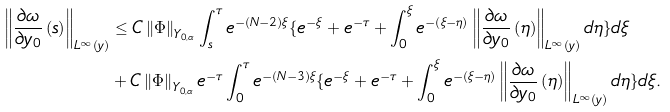Convert formula to latex. <formula><loc_0><loc_0><loc_500><loc_500>\left \| \frac { \partial \omega } { \partial y _ { 0 } } \left ( s \right ) \right \| _ { L ^ { \infty } \left ( y \right ) } & \leq C \left \| \Phi \right \| _ { Y _ { 0 , \alpha } } \int _ { s } ^ { \tau } e ^ { - \left ( N - 2 \right ) \xi } \{ e ^ { - \xi } + e ^ { - \tau } + \int _ { 0 } ^ { \xi } e ^ { - \left ( \xi - \eta \right ) } \left \| \frac { \partial \omega } { \partial y _ { 0 } } \left ( \eta \right ) \right \| _ { L ^ { \infty } \left ( y \right ) } d \eta \} d \xi \\ & + C \left \| \Phi \right \| _ { Y _ { 0 , \alpha } } e ^ { - \tau } \int _ { 0 } ^ { \tau } e ^ { - \left ( N - 3 \right ) \xi } \{ e ^ { - \xi } + e ^ { - \tau } + \int _ { 0 } ^ { \xi } e ^ { - \left ( \xi - \eta \right ) } \left \| \frac { \partial \omega } { \partial y _ { 0 } } \left ( \eta \right ) \right \| _ { L ^ { \infty } \left ( y \right ) } d \eta \} d \xi .</formula> 